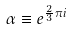Convert formula to latex. <formula><loc_0><loc_0><loc_500><loc_500>\alpha \equiv e ^ { \frac { 2 } { 3 } \pi i }</formula> 